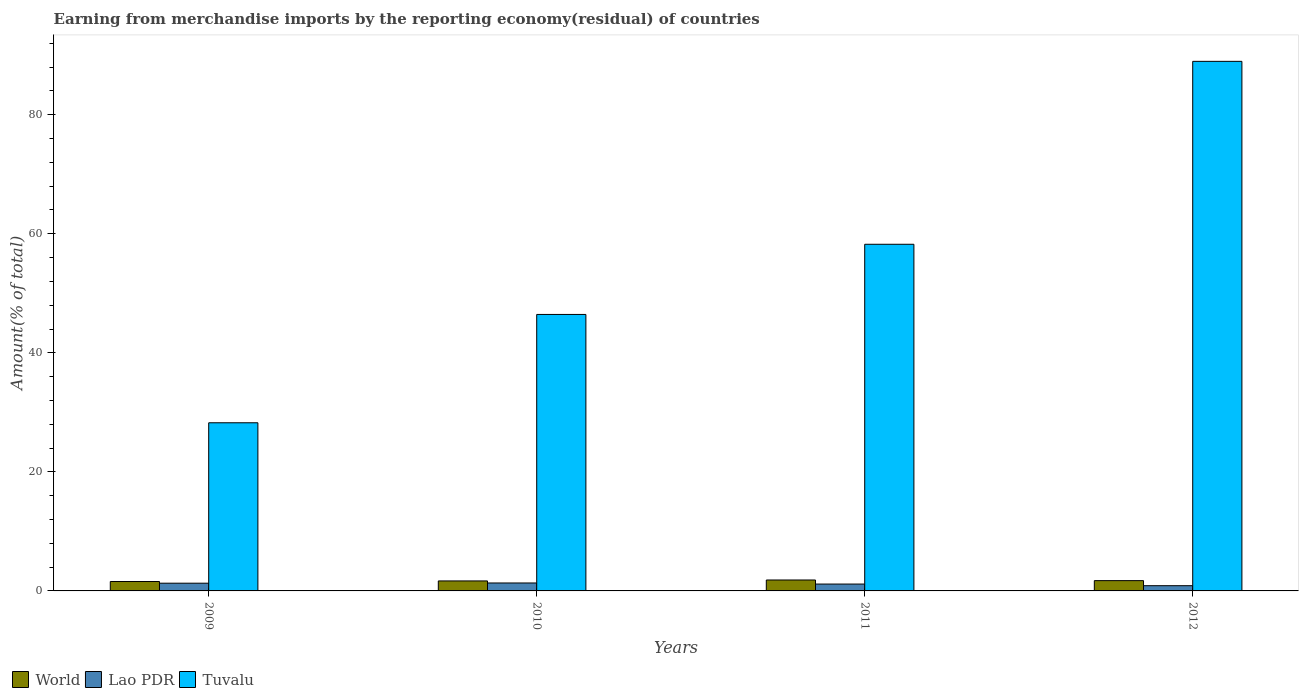How many different coloured bars are there?
Your answer should be compact. 3. How many groups of bars are there?
Offer a terse response. 4. Are the number of bars per tick equal to the number of legend labels?
Your answer should be compact. Yes. Are the number of bars on each tick of the X-axis equal?
Ensure brevity in your answer.  Yes. How many bars are there on the 4th tick from the right?
Ensure brevity in your answer.  3. What is the percentage of amount earned from merchandise imports in World in 2009?
Provide a short and direct response. 1.58. Across all years, what is the maximum percentage of amount earned from merchandise imports in World?
Your response must be concise. 1.84. Across all years, what is the minimum percentage of amount earned from merchandise imports in Tuvalu?
Your answer should be compact. 28.25. What is the total percentage of amount earned from merchandise imports in Lao PDR in the graph?
Provide a short and direct response. 4.67. What is the difference between the percentage of amount earned from merchandise imports in World in 2011 and that in 2012?
Offer a very short reply. 0.11. What is the difference between the percentage of amount earned from merchandise imports in Tuvalu in 2011 and the percentage of amount earned from merchandise imports in Lao PDR in 2009?
Provide a succinct answer. 56.94. What is the average percentage of amount earned from merchandise imports in World per year?
Ensure brevity in your answer.  1.71. In the year 2010, what is the difference between the percentage of amount earned from merchandise imports in Tuvalu and percentage of amount earned from merchandise imports in World?
Offer a very short reply. 44.77. What is the ratio of the percentage of amount earned from merchandise imports in Lao PDR in 2010 to that in 2011?
Offer a very short reply. 1.16. Is the percentage of amount earned from merchandise imports in World in 2009 less than that in 2011?
Make the answer very short. Yes. What is the difference between the highest and the second highest percentage of amount earned from merchandise imports in World?
Your answer should be very brief. 0.11. What is the difference between the highest and the lowest percentage of amount earned from merchandise imports in Lao PDR?
Provide a succinct answer. 0.46. In how many years, is the percentage of amount earned from merchandise imports in Tuvalu greater than the average percentage of amount earned from merchandise imports in Tuvalu taken over all years?
Your response must be concise. 2. What does the 2nd bar from the left in 2010 represents?
Offer a terse response. Lao PDR. What does the 2nd bar from the right in 2009 represents?
Give a very brief answer. Lao PDR. How many bars are there?
Your response must be concise. 12. Are all the bars in the graph horizontal?
Give a very brief answer. No. What is the difference between two consecutive major ticks on the Y-axis?
Make the answer very short. 20. Does the graph contain any zero values?
Your answer should be very brief. No. How many legend labels are there?
Offer a very short reply. 3. How are the legend labels stacked?
Offer a very short reply. Horizontal. What is the title of the graph?
Your answer should be very brief. Earning from merchandise imports by the reporting economy(residual) of countries. Does "Liberia" appear as one of the legend labels in the graph?
Ensure brevity in your answer.  No. What is the label or title of the Y-axis?
Provide a succinct answer. Amount(% of total). What is the Amount(% of total) in World in 2009?
Your answer should be very brief. 1.58. What is the Amount(% of total) in Lao PDR in 2009?
Your response must be concise. 1.3. What is the Amount(% of total) of Tuvalu in 2009?
Give a very brief answer. 28.25. What is the Amount(% of total) of World in 2010?
Provide a succinct answer. 1.68. What is the Amount(% of total) in Lao PDR in 2010?
Provide a succinct answer. 1.34. What is the Amount(% of total) in Tuvalu in 2010?
Give a very brief answer. 46.45. What is the Amount(% of total) in World in 2011?
Keep it short and to the point. 1.84. What is the Amount(% of total) in Lao PDR in 2011?
Offer a very short reply. 1.15. What is the Amount(% of total) in Tuvalu in 2011?
Provide a short and direct response. 58.24. What is the Amount(% of total) in World in 2012?
Keep it short and to the point. 1.73. What is the Amount(% of total) in Lao PDR in 2012?
Your answer should be very brief. 0.88. What is the Amount(% of total) of Tuvalu in 2012?
Offer a very short reply. 88.97. Across all years, what is the maximum Amount(% of total) in World?
Provide a succinct answer. 1.84. Across all years, what is the maximum Amount(% of total) in Lao PDR?
Provide a succinct answer. 1.34. Across all years, what is the maximum Amount(% of total) of Tuvalu?
Your response must be concise. 88.97. Across all years, what is the minimum Amount(% of total) of World?
Provide a short and direct response. 1.58. Across all years, what is the minimum Amount(% of total) of Lao PDR?
Your answer should be very brief. 0.88. Across all years, what is the minimum Amount(% of total) in Tuvalu?
Provide a short and direct response. 28.25. What is the total Amount(% of total) of World in the graph?
Give a very brief answer. 6.82. What is the total Amount(% of total) of Lao PDR in the graph?
Offer a terse response. 4.67. What is the total Amount(% of total) in Tuvalu in the graph?
Give a very brief answer. 221.91. What is the difference between the Amount(% of total) in World in 2009 and that in 2010?
Provide a succinct answer. -0.1. What is the difference between the Amount(% of total) in Lao PDR in 2009 and that in 2010?
Offer a terse response. -0.04. What is the difference between the Amount(% of total) of Tuvalu in 2009 and that in 2010?
Ensure brevity in your answer.  -18.2. What is the difference between the Amount(% of total) of World in 2009 and that in 2011?
Your answer should be compact. -0.26. What is the difference between the Amount(% of total) in Lao PDR in 2009 and that in 2011?
Give a very brief answer. 0.15. What is the difference between the Amount(% of total) in Tuvalu in 2009 and that in 2011?
Offer a terse response. -29.99. What is the difference between the Amount(% of total) of World in 2009 and that in 2012?
Offer a terse response. -0.15. What is the difference between the Amount(% of total) in Lao PDR in 2009 and that in 2012?
Your answer should be compact. 0.42. What is the difference between the Amount(% of total) in Tuvalu in 2009 and that in 2012?
Ensure brevity in your answer.  -60.72. What is the difference between the Amount(% of total) of World in 2010 and that in 2011?
Offer a terse response. -0.16. What is the difference between the Amount(% of total) in Lao PDR in 2010 and that in 2011?
Give a very brief answer. 0.18. What is the difference between the Amount(% of total) in Tuvalu in 2010 and that in 2011?
Keep it short and to the point. -11.79. What is the difference between the Amount(% of total) of World in 2010 and that in 2012?
Provide a succinct answer. -0.05. What is the difference between the Amount(% of total) of Lao PDR in 2010 and that in 2012?
Provide a succinct answer. 0.46. What is the difference between the Amount(% of total) in Tuvalu in 2010 and that in 2012?
Offer a terse response. -42.52. What is the difference between the Amount(% of total) of World in 2011 and that in 2012?
Ensure brevity in your answer.  0.11. What is the difference between the Amount(% of total) of Lao PDR in 2011 and that in 2012?
Offer a very short reply. 0.27. What is the difference between the Amount(% of total) in Tuvalu in 2011 and that in 2012?
Offer a terse response. -30.73. What is the difference between the Amount(% of total) of World in 2009 and the Amount(% of total) of Lao PDR in 2010?
Your answer should be very brief. 0.25. What is the difference between the Amount(% of total) of World in 2009 and the Amount(% of total) of Tuvalu in 2010?
Your answer should be very brief. -44.87. What is the difference between the Amount(% of total) of Lao PDR in 2009 and the Amount(% of total) of Tuvalu in 2010?
Offer a very short reply. -45.15. What is the difference between the Amount(% of total) of World in 2009 and the Amount(% of total) of Lao PDR in 2011?
Provide a short and direct response. 0.43. What is the difference between the Amount(% of total) in World in 2009 and the Amount(% of total) in Tuvalu in 2011?
Give a very brief answer. -56.66. What is the difference between the Amount(% of total) of Lao PDR in 2009 and the Amount(% of total) of Tuvalu in 2011?
Offer a very short reply. -56.94. What is the difference between the Amount(% of total) in World in 2009 and the Amount(% of total) in Lao PDR in 2012?
Offer a terse response. 0.7. What is the difference between the Amount(% of total) in World in 2009 and the Amount(% of total) in Tuvalu in 2012?
Your answer should be very brief. -87.39. What is the difference between the Amount(% of total) of Lao PDR in 2009 and the Amount(% of total) of Tuvalu in 2012?
Your answer should be very brief. -87.67. What is the difference between the Amount(% of total) of World in 2010 and the Amount(% of total) of Lao PDR in 2011?
Offer a terse response. 0.52. What is the difference between the Amount(% of total) in World in 2010 and the Amount(% of total) in Tuvalu in 2011?
Offer a terse response. -56.56. What is the difference between the Amount(% of total) in Lao PDR in 2010 and the Amount(% of total) in Tuvalu in 2011?
Keep it short and to the point. -56.91. What is the difference between the Amount(% of total) in World in 2010 and the Amount(% of total) in Lao PDR in 2012?
Ensure brevity in your answer.  0.8. What is the difference between the Amount(% of total) of World in 2010 and the Amount(% of total) of Tuvalu in 2012?
Offer a terse response. -87.29. What is the difference between the Amount(% of total) in Lao PDR in 2010 and the Amount(% of total) in Tuvalu in 2012?
Give a very brief answer. -87.64. What is the difference between the Amount(% of total) in World in 2011 and the Amount(% of total) in Tuvalu in 2012?
Provide a short and direct response. -87.13. What is the difference between the Amount(% of total) in Lao PDR in 2011 and the Amount(% of total) in Tuvalu in 2012?
Your answer should be compact. -87.82. What is the average Amount(% of total) of World per year?
Make the answer very short. 1.71. What is the average Amount(% of total) in Lao PDR per year?
Provide a short and direct response. 1.17. What is the average Amount(% of total) of Tuvalu per year?
Your answer should be very brief. 55.48. In the year 2009, what is the difference between the Amount(% of total) in World and Amount(% of total) in Lao PDR?
Ensure brevity in your answer.  0.28. In the year 2009, what is the difference between the Amount(% of total) in World and Amount(% of total) in Tuvalu?
Your response must be concise. -26.67. In the year 2009, what is the difference between the Amount(% of total) of Lao PDR and Amount(% of total) of Tuvalu?
Make the answer very short. -26.95. In the year 2010, what is the difference between the Amount(% of total) of World and Amount(% of total) of Lao PDR?
Your response must be concise. 0.34. In the year 2010, what is the difference between the Amount(% of total) of World and Amount(% of total) of Tuvalu?
Your response must be concise. -44.77. In the year 2010, what is the difference between the Amount(% of total) in Lao PDR and Amount(% of total) in Tuvalu?
Give a very brief answer. -45.11. In the year 2011, what is the difference between the Amount(% of total) of World and Amount(% of total) of Lao PDR?
Offer a very short reply. 0.68. In the year 2011, what is the difference between the Amount(% of total) of World and Amount(% of total) of Tuvalu?
Provide a succinct answer. -56.4. In the year 2011, what is the difference between the Amount(% of total) in Lao PDR and Amount(% of total) in Tuvalu?
Your answer should be very brief. -57.09. In the year 2012, what is the difference between the Amount(% of total) of World and Amount(% of total) of Lao PDR?
Offer a very short reply. 0.85. In the year 2012, what is the difference between the Amount(% of total) in World and Amount(% of total) in Tuvalu?
Provide a short and direct response. -87.24. In the year 2012, what is the difference between the Amount(% of total) of Lao PDR and Amount(% of total) of Tuvalu?
Your answer should be compact. -88.09. What is the ratio of the Amount(% of total) in World in 2009 to that in 2010?
Your answer should be very brief. 0.94. What is the ratio of the Amount(% of total) in Tuvalu in 2009 to that in 2010?
Offer a very short reply. 0.61. What is the ratio of the Amount(% of total) in World in 2009 to that in 2011?
Offer a terse response. 0.86. What is the ratio of the Amount(% of total) in Lao PDR in 2009 to that in 2011?
Offer a terse response. 1.13. What is the ratio of the Amount(% of total) in Tuvalu in 2009 to that in 2011?
Offer a terse response. 0.49. What is the ratio of the Amount(% of total) in World in 2009 to that in 2012?
Your answer should be compact. 0.91. What is the ratio of the Amount(% of total) of Lao PDR in 2009 to that in 2012?
Offer a terse response. 1.48. What is the ratio of the Amount(% of total) in Tuvalu in 2009 to that in 2012?
Make the answer very short. 0.32. What is the ratio of the Amount(% of total) in World in 2010 to that in 2011?
Keep it short and to the point. 0.91. What is the ratio of the Amount(% of total) of Lao PDR in 2010 to that in 2011?
Your answer should be compact. 1.16. What is the ratio of the Amount(% of total) of Tuvalu in 2010 to that in 2011?
Offer a terse response. 0.8. What is the ratio of the Amount(% of total) in World in 2010 to that in 2012?
Offer a very short reply. 0.97. What is the ratio of the Amount(% of total) in Lao PDR in 2010 to that in 2012?
Give a very brief answer. 1.52. What is the ratio of the Amount(% of total) of Tuvalu in 2010 to that in 2012?
Provide a succinct answer. 0.52. What is the ratio of the Amount(% of total) of World in 2011 to that in 2012?
Provide a short and direct response. 1.06. What is the ratio of the Amount(% of total) in Lao PDR in 2011 to that in 2012?
Offer a terse response. 1.31. What is the ratio of the Amount(% of total) in Tuvalu in 2011 to that in 2012?
Your response must be concise. 0.65. What is the difference between the highest and the second highest Amount(% of total) in World?
Provide a short and direct response. 0.11. What is the difference between the highest and the second highest Amount(% of total) in Lao PDR?
Provide a short and direct response. 0.04. What is the difference between the highest and the second highest Amount(% of total) in Tuvalu?
Give a very brief answer. 30.73. What is the difference between the highest and the lowest Amount(% of total) in World?
Provide a succinct answer. 0.26. What is the difference between the highest and the lowest Amount(% of total) of Lao PDR?
Offer a terse response. 0.46. What is the difference between the highest and the lowest Amount(% of total) of Tuvalu?
Provide a short and direct response. 60.72. 